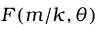Convert formula to latex. <formula><loc_0><loc_0><loc_500><loc_500>F ( m / k , \theta )</formula> 